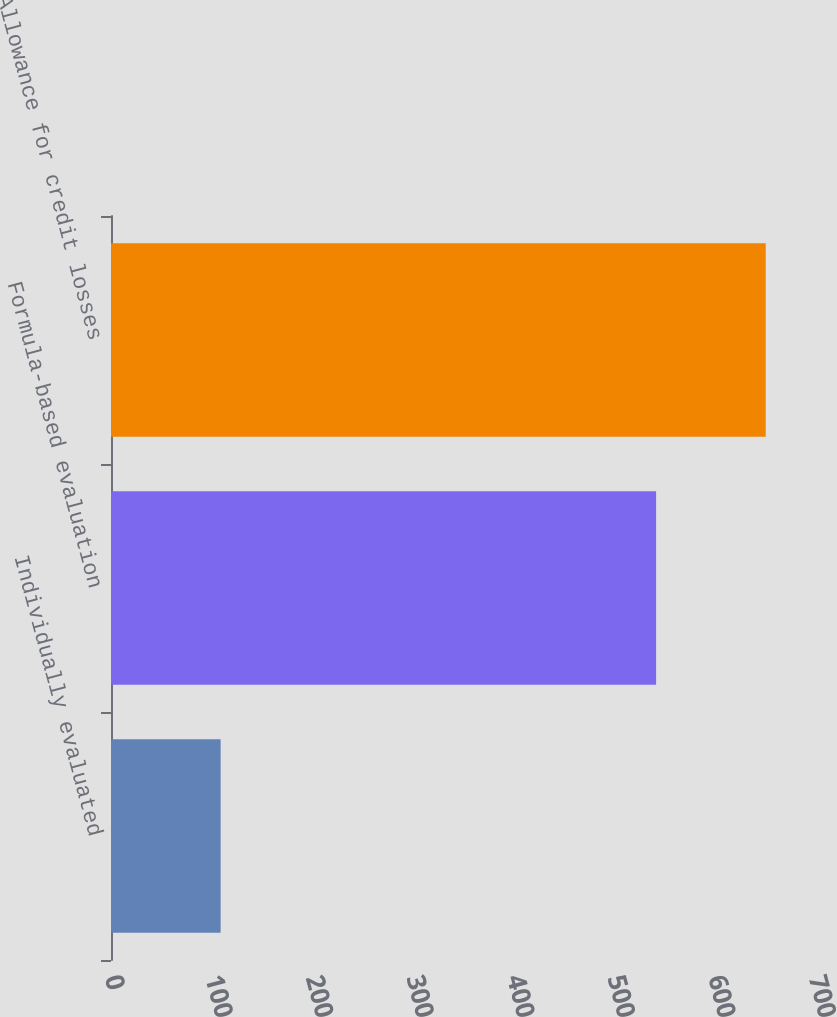Convert chart to OTSL. <chart><loc_0><loc_0><loc_500><loc_500><bar_chart><fcel>Individually evaluated<fcel>Formula-based evaluation<fcel>Allowance for credit losses<nl><fcel>109<fcel>542<fcel>651<nl></chart> 